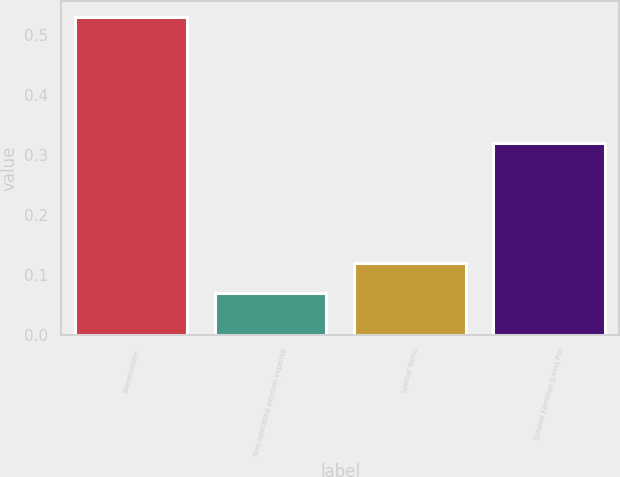Convert chart. <chart><loc_0><loc_0><loc_500><loc_500><bar_chart><fcel>Shareholders<fcel>Non-operating pension expense<fcel>Special items<fcel>Diluted Earnings (Loss) Per<nl><fcel>0.53<fcel>0.07<fcel>0.12<fcel>0.32<nl></chart> 